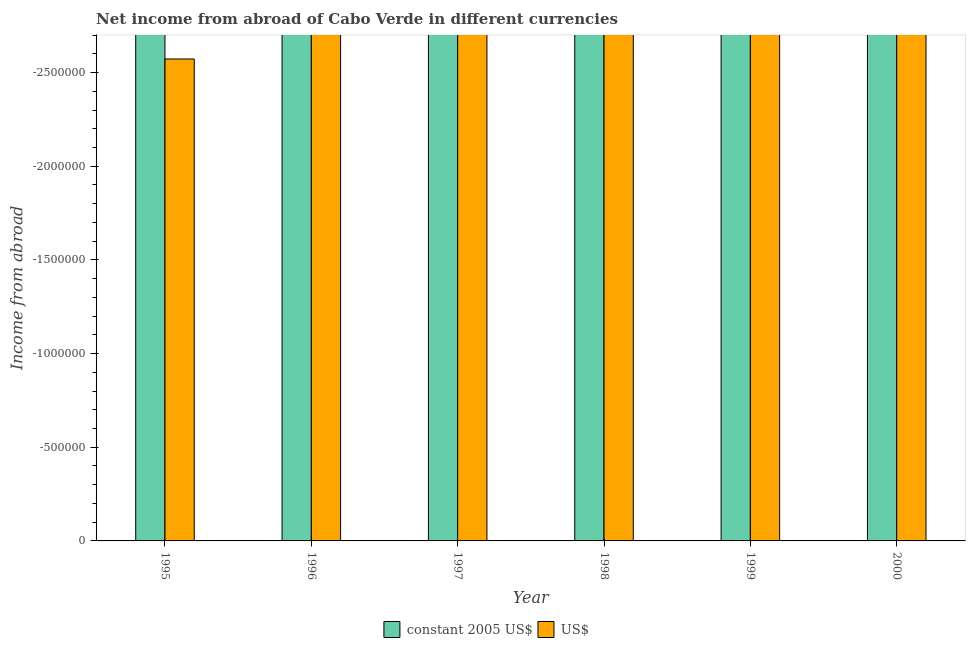How many different coloured bars are there?
Ensure brevity in your answer.  0. Are the number of bars on each tick of the X-axis equal?
Offer a terse response. Yes. How many bars are there on the 2nd tick from the left?
Make the answer very short. 0. Across all years, what is the minimum income from abroad in us$?
Make the answer very short. 0. How many bars are there?
Offer a terse response. 0. How many years are there in the graph?
Ensure brevity in your answer.  6. What is the difference between two consecutive major ticks on the Y-axis?
Your response must be concise. 5.00e+05. How many legend labels are there?
Give a very brief answer. 2. How are the legend labels stacked?
Give a very brief answer. Horizontal. What is the title of the graph?
Make the answer very short. Net income from abroad of Cabo Verde in different currencies. What is the label or title of the X-axis?
Offer a terse response. Year. What is the label or title of the Y-axis?
Your response must be concise. Income from abroad. What is the Income from abroad of constant 2005 US$ in 1995?
Your response must be concise. 0. What is the Income from abroad of US$ in 1995?
Provide a short and direct response. 0. What is the Income from abroad of constant 2005 US$ in 1996?
Give a very brief answer. 0. What is the Income from abroad of US$ in 1996?
Your answer should be very brief. 0. What is the Income from abroad in constant 2005 US$ in 1997?
Ensure brevity in your answer.  0. What is the Income from abroad in constant 2005 US$ in 1999?
Your answer should be compact. 0. What is the total Income from abroad of US$ in the graph?
Provide a short and direct response. 0. 